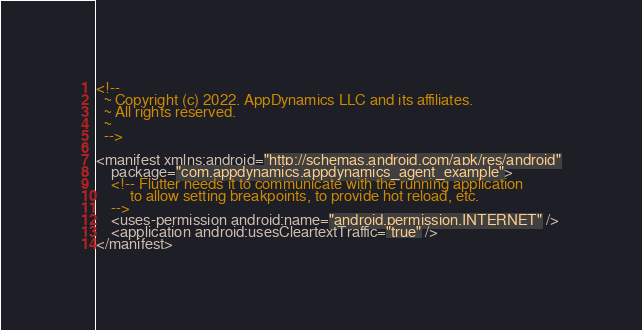Convert code to text. <code><loc_0><loc_0><loc_500><loc_500><_XML_><!--
  ~ Copyright (c) 2022. AppDynamics LLC and its affiliates.
  ~ All rights reserved.
  ~
  -->

<manifest xmlns:android="http://schemas.android.com/apk/res/android"
    package="com.appdynamics.appdynamics_agent_example">
    <!-- Flutter needs it to communicate with the running application
         to allow setting breakpoints, to provide hot reload, etc.
    -->
    <uses-permission android:name="android.permission.INTERNET" />
    <application android:usesCleartextTraffic="true" />
</manifest>
</code> 